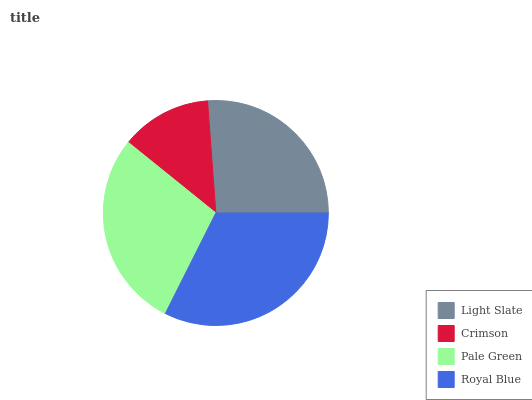Is Crimson the minimum?
Answer yes or no. Yes. Is Royal Blue the maximum?
Answer yes or no. Yes. Is Pale Green the minimum?
Answer yes or no. No. Is Pale Green the maximum?
Answer yes or no. No. Is Pale Green greater than Crimson?
Answer yes or no. Yes. Is Crimson less than Pale Green?
Answer yes or no. Yes. Is Crimson greater than Pale Green?
Answer yes or no. No. Is Pale Green less than Crimson?
Answer yes or no. No. Is Pale Green the high median?
Answer yes or no. Yes. Is Light Slate the low median?
Answer yes or no. Yes. Is Light Slate the high median?
Answer yes or no. No. Is Crimson the low median?
Answer yes or no. No. 